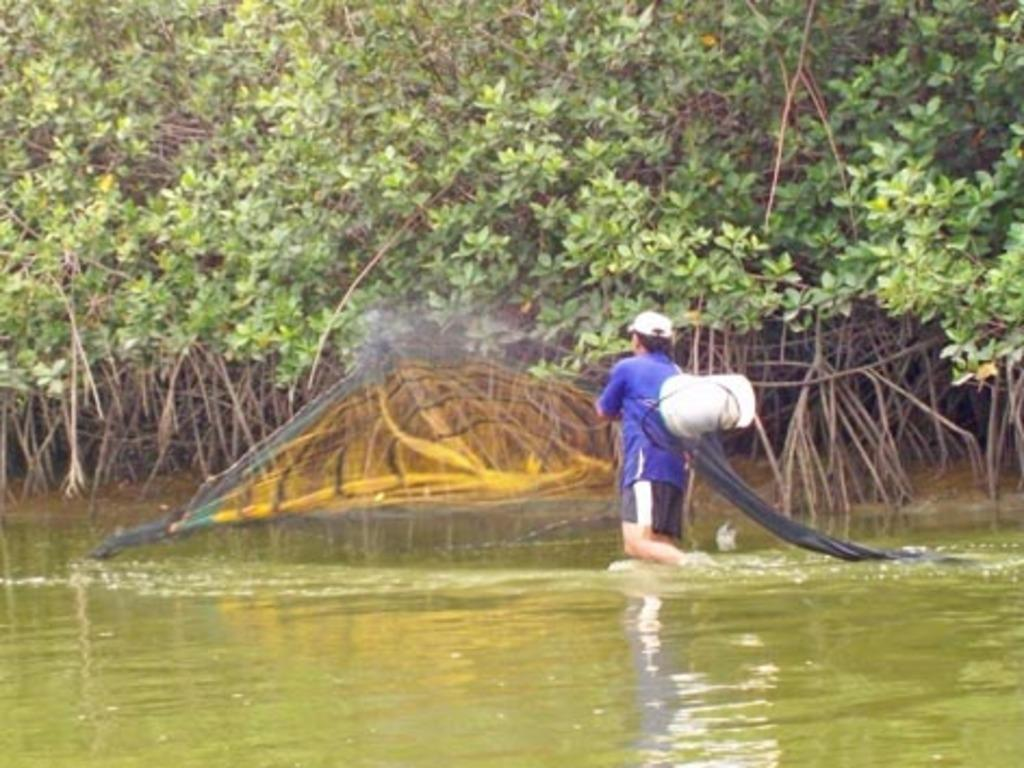What is the man doing in the water? The man is in the water, carrying a bucket and holding a net. What objects is the man holding in the water? The man is carrying a bucket and holding a net. What can be seen in the background of the image? There are trees visible in the background. What color is the rose that the man is painting in the image? There is no rose or painting activity present in the image. 